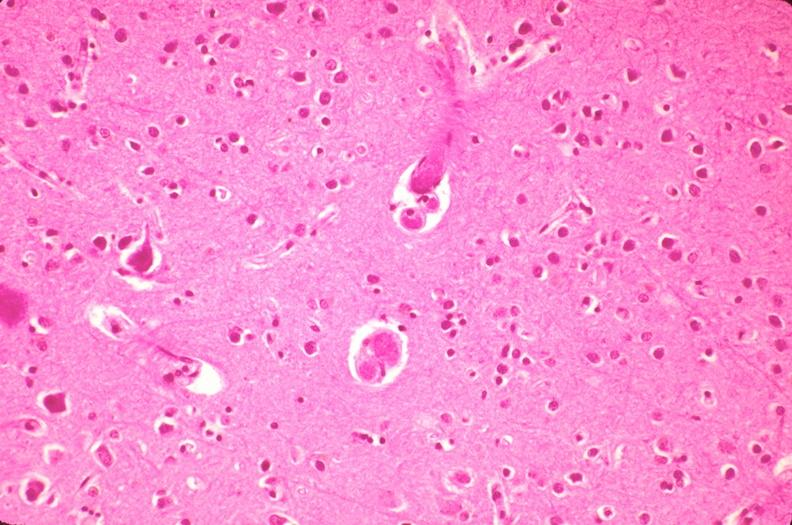where is this?
Answer the question using a single word or phrase. Nervous 